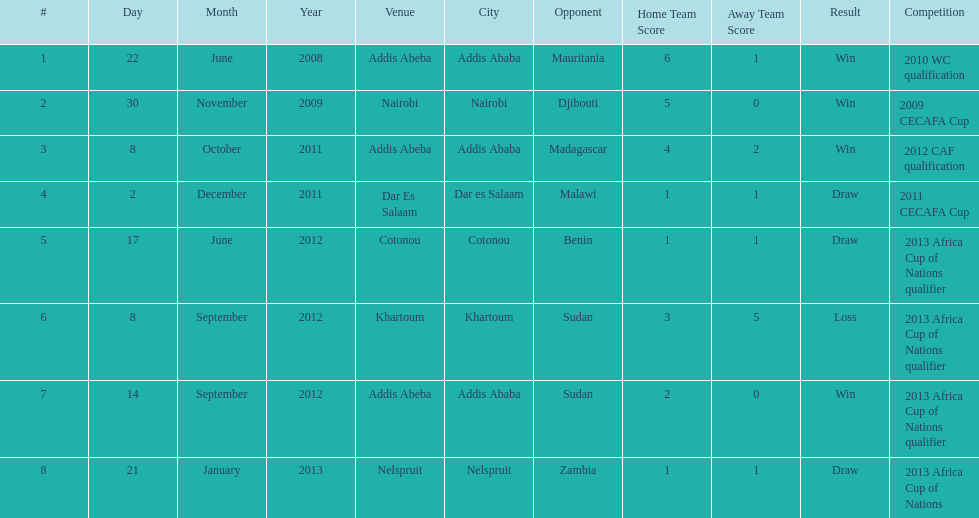Number of different teams listed on the chart 7. 